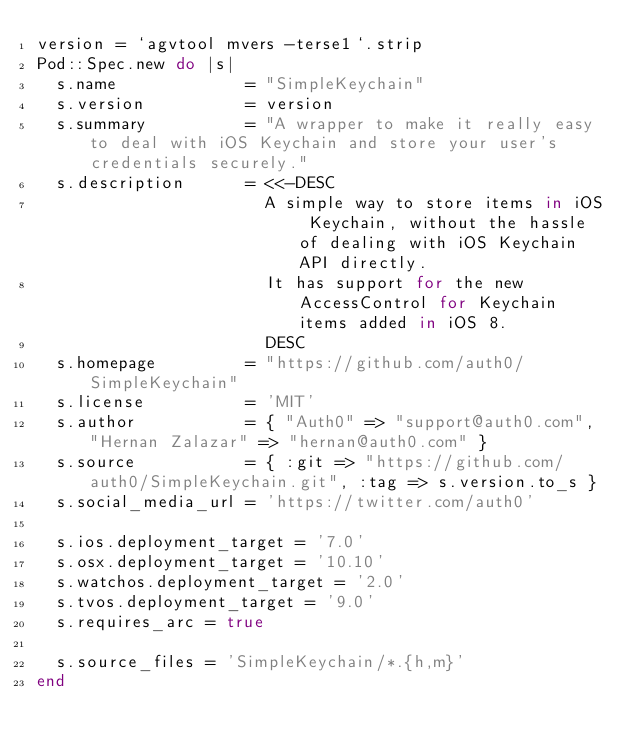Convert code to text. <code><loc_0><loc_0><loc_500><loc_500><_Ruby_>version = `agvtool mvers -terse1`.strip
Pod::Spec.new do |s|
  s.name             = "SimpleKeychain"
  s.version          = version
  s.summary          = "A wrapper to make it really easy to deal with iOS Keychain and store your user's credentials securely."
  s.description      = <<-DESC
                       A simple way to store items in iOS Keychain, without the hassle of dealing with iOS Keychain API directly.
                       It has support for the new AccessControl for Keychain items added in iOS 8.
                       DESC
  s.homepage         = "https://github.com/auth0/SimpleKeychain"
  s.license          = 'MIT'
  s.author           = { "Auth0" => "support@auth0.com", "Hernan Zalazar" => "hernan@auth0.com" }
  s.source           = { :git => "https://github.com/auth0/SimpleKeychain.git", :tag => s.version.to_s }
  s.social_media_url = 'https://twitter.com/auth0'

  s.ios.deployment_target = '7.0'
  s.osx.deployment_target = '10.10'
  s.watchos.deployment_target = '2.0'
  s.tvos.deployment_target = '9.0'
  s.requires_arc = true

  s.source_files = 'SimpleKeychain/*.{h,m}'
end
</code> 